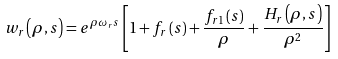Convert formula to latex. <formula><loc_0><loc_0><loc_500><loc_500>w _ { r } \left ( \rho , s \right ) = e ^ { \rho \omega _ { r } s } \left [ 1 + f _ { r } \left ( s \right ) + \frac { f _ { r 1 } \left ( s \right ) } { \rho } + \frac { H _ { r } \left ( \rho , s \right ) } { \rho ^ { 2 } } \right ]</formula> 